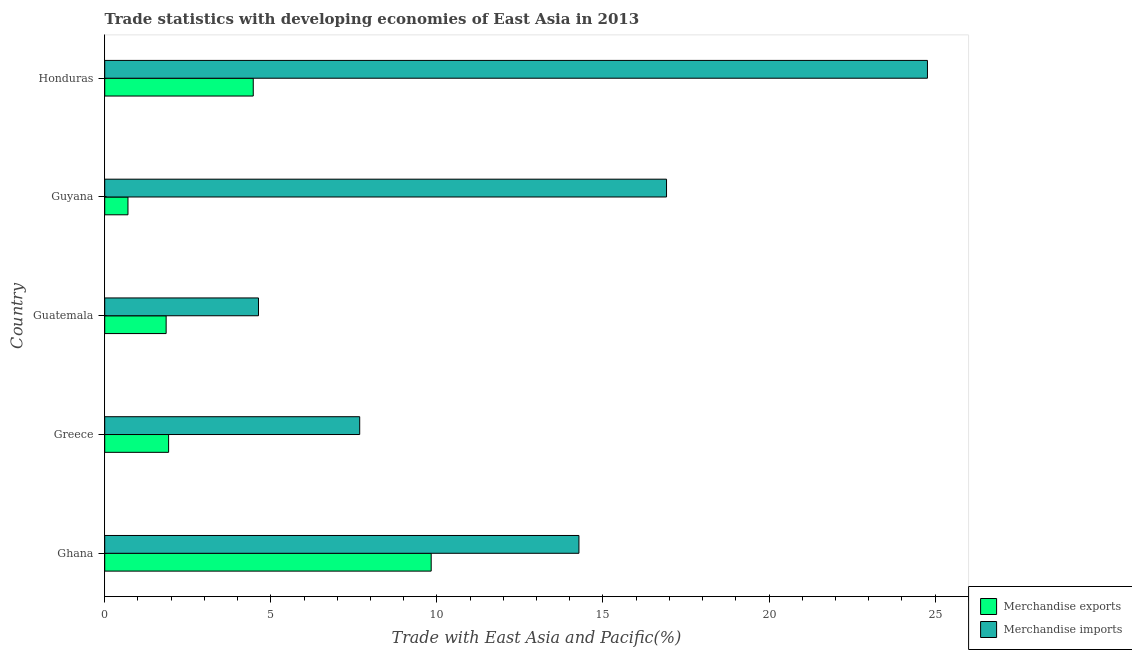How many different coloured bars are there?
Offer a terse response. 2. How many groups of bars are there?
Keep it short and to the point. 5. Are the number of bars on each tick of the Y-axis equal?
Provide a succinct answer. Yes. How many bars are there on the 1st tick from the top?
Provide a short and direct response. 2. What is the label of the 1st group of bars from the top?
Ensure brevity in your answer.  Honduras. In how many cases, is the number of bars for a given country not equal to the number of legend labels?
Make the answer very short. 0. What is the merchandise imports in Honduras?
Your answer should be very brief. 24.77. Across all countries, what is the maximum merchandise imports?
Offer a terse response. 24.77. Across all countries, what is the minimum merchandise imports?
Make the answer very short. 4.63. In which country was the merchandise exports maximum?
Your answer should be compact. Ghana. In which country was the merchandise exports minimum?
Keep it short and to the point. Guyana. What is the total merchandise exports in the graph?
Ensure brevity in your answer.  18.77. What is the difference between the merchandise exports in Guatemala and that in Honduras?
Provide a short and direct response. -2.62. What is the difference between the merchandise exports in Guyana and the merchandise imports in Greece?
Keep it short and to the point. -6.98. What is the average merchandise exports per country?
Make the answer very short. 3.75. What is the difference between the merchandise exports and merchandise imports in Honduras?
Your answer should be compact. -20.3. In how many countries, is the merchandise exports greater than 22 %?
Ensure brevity in your answer.  0. What is the ratio of the merchandise imports in Guyana to that in Honduras?
Provide a succinct answer. 0.68. What is the difference between the highest and the second highest merchandise imports?
Provide a succinct answer. 7.86. What is the difference between the highest and the lowest merchandise imports?
Ensure brevity in your answer.  20.14. Is the sum of the merchandise exports in Guatemala and Guyana greater than the maximum merchandise imports across all countries?
Provide a short and direct response. No. What does the 2nd bar from the top in Greece represents?
Give a very brief answer. Merchandise exports. How many bars are there?
Provide a succinct answer. 10. Are the values on the major ticks of X-axis written in scientific E-notation?
Your answer should be very brief. No. Does the graph contain any zero values?
Keep it short and to the point. No. How are the legend labels stacked?
Ensure brevity in your answer.  Vertical. What is the title of the graph?
Your answer should be very brief. Trade statistics with developing economies of East Asia in 2013. What is the label or title of the X-axis?
Give a very brief answer. Trade with East Asia and Pacific(%). What is the Trade with East Asia and Pacific(%) in Merchandise exports in Ghana?
Provide a short and direct response. 9.83. What is the Trade with East Asia and Pacific(%) in Merchandise imports in Ghana?
Your answer should be very brief. 14.28. What is the Trade with East Asia and Pacific(%) of Merchandise exports in Greece?
Your answer should be very brief. 1.92. What is the Trade with East Asia and Pacific(%) in Merchandise imports in Greece?
Provide a succinct answer. 7.68. What is the Trade with East Asia and Pacific(%) of Merchandise exports in Guatemala?
Offer a terse response. 1.85. What is the Trade with East Asia and Pacific(%) in Merchandise imports in Guatemala?
Your response must be concise. 4.63. What is the Trade with East Asia and Pacific(%) of Merchandise exports in Guyana?
Your response must be concise. 0.7. What is the Trade with East Asia and Pacific(%) of Merchandise imports in Guyana?
Provide a succinct answer. 16.91. What is the Trade with East Asia and Pacific(%) in Merchandise exports in Honduras?
Keep it short and to the point. 4.47. What is the Trade with East Asia and Pacific(%) of Merchandise imports in Honduras?
Offer a very short reply. 24.77. Across all countries, what is the maximum Trade with East Asia and Pacific(%) in Merchandise exports?
Keep it short and to the point. 9.83. Across all countries, what is the maximum Trade with East Asia and Pacific(%) in Merchandise imports?
Your answer should be very brief. 24.77. Across all countries, what is the minimum Trade with East Asia and Pacific(%) of Merchandise exports?
Keep it short and to the point. 0.7. Across all countries, what is the minimum Trade with East Asia and Pacific(%) in Merchandise imports?
Ensure brevity in your answer.  4.63. What is the total Trade with East Asia and Pacific(%) of Merchandise exports in the graph?
Give a very brief answer. 18.77. What is the total Trade with East Asia and Pacific(%) in Merchandise imports in the graph?
Your response must be concise. 68.27. What is the difference between the Trade with East Asia and Pacific(%) of Merchandise exports in Ghana and that in Greece?
Keep it short and to the point. 7.91. What is the difference between the Trade with East Asia and Pacific(%) of Merchandise imports in Ghana and that in Greece?
Keep it short and to the point. 6.6. What is the difference between the Trade with East Asia and Pacific(%) of Merchandise exports in Ghana and that in Guatemala?
Ensure brevity in your answer.  7.98. What is the difference between the Trade with East Asia and Pacific(%) of Merchandise imports in Ghana and that in Guatemala?
Make the answer very short. 9.65. What is the difference between the Trade with East Asia and Pacific(%) in Merchandise exports in Ghana and that in Guyana?
Your response must be concise. 9.13. What is the difference between the Trade with East Asia and Pacific(%) of Merchandise imports in Ghana and that in Guyana?
Your answer should be very brief. -2.64. What is the difference between the Trade with East Asia and Pacific(%) of Merchandise exports in Ghana and that in Honduras?
Provide a succinct answer. 5.36. What is the difference between the Trade with East Asia and Pacific(%) of Merchandise imports in Ghana and that in Honduras?
Ensure brevity in your answer.  -10.49. What is the difference between the Trade with East Asia and Pacific(%) in Merchandise exports in Greece and that in Guatemala?
Give a very brief answer. 0.07. What is the difference between the Trade with East Asia and Pacific(%) in Merchandise imports in Greece and that in Guatemala?
Keep it short and to the point. 3.05. What is the difference between the Trade with East Asia and Pacific(%) of Merchandise exports in Greece and that in Guyana?
Your response must be concise. 1.22. What is the difference between the Trade with East Asia and Pacific(%) in Merchandise imports in Greece and that in Guyana?
Offer a terse response. -9.24. What is the difference between the Trade with East Asia and Pacific(%) of Merchandise exports in Greece and that in Honduras?
Keep it short and to the point. -2.55. What is the difference between the Trade with East Asia and Pacific(%) of Merchandise imports in Greece and that in Honduras?
Offer a terse response. -17.09. What is the difference between the Trade with East Asia and Pacific(%) of Merchandise exports in Guatemala and that in Guyana?
Your answer should be compact. 1.15. What is the difference between the Trade with East Asia and Pacific(%) in Merchandise imports in Guatemala and that in Guyana?
Ensure brevity in your answer.  -12.28. What is the difference between the Trade with East Asia and Pacific(%) in Merchandise exports in Guatemala and that in Honduras?
Make the answer very short. -2.62. What is the difference between the Trade with East Asia and Pacific(%) in Merchandise imports in Guatemala and that in Honduras?
Your response must be concise. -20.14. What is the difference between the Trade with East Asia and Pacific(%) of Merchandise exports in Guyana and that in Honduras?
Offer a very short reply. -3.77. What is the difference between the Trade with East Asia and Pacific(%) in Merchandise imports in Guyana and that in Honduras?
Give a very brief answer. -7.86. What is the difference between the Trade with East Asia and Pacific(%) in Merchandise exports in Ghana and the Trade with East Asia and Pacific(%) in Merchandise imports in Greece?
Keep it short and to the point. 2.15. What is the difference between the Trade with East Asia and Pacific(%) of Merchandise exports in Ghana and the Trade with East Asia and Pacific(%) of Merchandise imports in Guatemala?
Ensure brevity in your answer.  5.2. What is the difference between the Trade with East Asia and Pacific(%) of Merchandise exports in Ghana and the Trade with East Asia and Pacific(%) of Merchandise imports in Guyana?
Your response must be concise. -7.09. What is the difference between the Trade with East Asia and Pacific(%) of Merchandise exports in Ghana and the Trade with East Asia and Pacific(%) of Merchandise imports in Honduras?
Ensure brevity in your answer.  -14.94. What is the difference between the Trade with East Asia and Pacific(%) of Merchandise exports in Greece and the Trade with East Asia and Pacific(%) of Merchandise imports in Guatemala?
Provide a succinct answer. -2.71. What is the difference between the Trade with East Asia and Pacific(%) of Merchandise exports in Greece and the Trade with East Asia and Pacific(%) of Merchandise imports in Guyana?
Offer a very short reply. -14.99. What is the difference between the Trade with East Asia and Pacific(%) of Merchandise exports in Greece and the Trade with East Asia and Pacific(%) of Merchandise imports in Honduras?
Your answer should be very brief. -22.85. What is the difference between the Trade with East Asia and Pacific(%) of Merchandise exports in Guatemala and the Trade with East Asia and Pacific(%) of Merchandise imports in Guyana?
Keep it short and to the point. -15.07. What is the difference between the Trade with East Asia and Pacific(%) in Merchandise exports in Guatemala and the Trade with East Asia and Pacific(%) in Merchandise imports in Honduras?
Give a very brief answer. -22.92. What is the difference between the Trade with East Asia and Pacific(%) in Merchandise exports in Guyana and the Trade with East Asia and Pacific(%) in Merchandise imports in Honduras?
Make the answer very short. -24.07. What is the average Trade with East Asia and Pacific(%) in Merchandise exports per country?
Offer a very short reply. 3.75. What is the average Trade with East Asia and Pacific(%) of Merchandise imports per country?
Ensure brevity in your answer.  13.65. What is the difference between the Trade with East Asia and Pacific(%) in Merchandise exports and Trade with East Asia and Pacific(%) in Merchandise imports in Ghana?
Make the answer very short. -4.45. What is the difference between the Trade with East Asia and Pacific(%) in Merchandise exports and Trade with East Asia and Pacific(%) in Merchandise imports in Greece?
Your answer should be compact. -5.75. What is the difference between the Trade with East Asia and Pacific(%) of Merchandise exports and Trade with East Asia and Pacific(%) of Merchandise imports in Guatemala?
Provide a succinct answer. -2.78. What is the difference between the Trade with East Asia and Pacific(%) of Merchandise exports and Trade with East Asia and Pacific(%) of Merchandise imports in Guyana?
Offer a terse response. -16.21. What is the difference between the Trade with East Asia and Pacific(%) of Merchandise exports and Trade with East Asia and Pacific(%) of Merchandise imports in Honduras?
Keep it short and to the point. -20.3. What is the ratio of the Trade with East Asia and Pacific(%) in Merchandise exports in Ghana to that in Greece?
Your answer should be very brief. 5.11. What is the ratio of the Trade with East Asia and Pacific(%) in Merchandise imports in Ghana to that in Greece?
Provide a short and direct response. 1.86. What is the ratio of the Trade with East Asia and Pacific(%) of Merchandise exports in Ghana to that in Guatemala?
Offer a terse response. 5.32. What is the ratio of the Trade with East Asia and Pacific(%) of Merchandise imports in Ghana to that in Guatemala?
Your answer should be very brief. 3.08. What is the ratio of the Trade with East Asia and Pacific(%) of Merchandise exports in Ghana to that in Guyana?
Your answer should be very brief. 14.04. What is the ratio of the Trade with East Asia and Pacific(%) in Merchandise imports in Ghana to that in Guyana?
Provide a succinct answer. 0.84. What is the ratio of the Trade with East Asia and Pacific(%) of Merchandise exports in Ghana to that in Honduras?
Your response must be concise. 2.2. What is the ratio of the Trade with East Asia and Pacific(%) in Merchandise imports in Ghana to that in Honduras?
Provide a succinct answer. 0.58. What is the ratio of the Trade with East Asia and Pacific(%) of Merchandise exports in Greece to that in Guatemala?
Provide a short and direct response. 1.04. What is the ratio of the Trade with East Asia and Pacific(%) of Merchandise imports in Greece to that in Guatemala?
Offer a very short reply. 1.66. What is the ratio of the Trade with East Asia and Pacific(%) in Merchandise exports in Greece to that in Guyana?
Give a very brief answer. 2.75. What is the ratio of the Trade with East Asia and Pacific(%) in Merchandise imports in Greece to that in Guyana?
Provide a succinct answer. 0.45. What is the ratio of the Trade with East Asia and Pacific(%) in Merchandise exports in Greece to that in Honduras?
Your response must be concise. 0.43. What is the ratio of the Trade with East Asia and Pacific(%) in Merchandise imports in Greece to that in Honduras?
Your answer should be compact. 0.31. What is the ratio of the Trade with East Asia and Pacific(%) in Merchandise exports in Guatemala to that in Guyana?
Your answer should be very brief. 2.64. What is the ratio of the Trade with East Asia and Pacific(%) of Merchandise imports in Guatemala to that in Guyana?
Provide a short and direct response. 0.27. What is the ratio of the Trade with East Asia and Pacific(%) of Merchandise exports in Guatemala to that in Honduras?
Give a very brief answer. 0.41. What is the ratio of the Trade with East Asia and Pacific(%) in Merchandise imports in Guatemala to that in Honduras?
Offer a very short reply. 0.19. What is the ratio of the Trade with East Asia and Pacific(%) of Merchandise exports in Guyana to that in Honduras?
Make the answer very short. 0.16. What is the ratio of the Trade with East Asia and Pacific(%) in Merchandise imports in Guyana to that in Honduras?
Make the answer very short. 0.68. What is the difference between the highest and the second highest Trade with East Asia and Pacific(%) of Merchandise exports?
Your answer should be compact. 5.36. What is the difference between the highest and the second highest Trade with East Asia and Pacific(%) of Merchandise imports?
Offer a terse response. 7.86. What is the difference between the highest and the lowest Trade with East Asia and Pacific(%) in Merchandise exports?
Keep it short and to the point. 9.13. What is the difference between the highest and the lowest Trade with East Asia and Pacific(%) of Merchandise imports?
Your response must be concise. 20.14. 